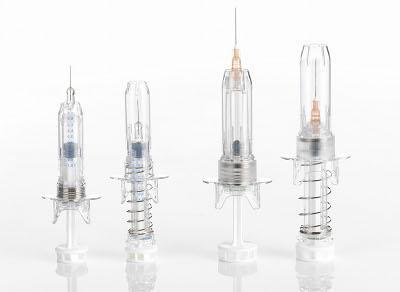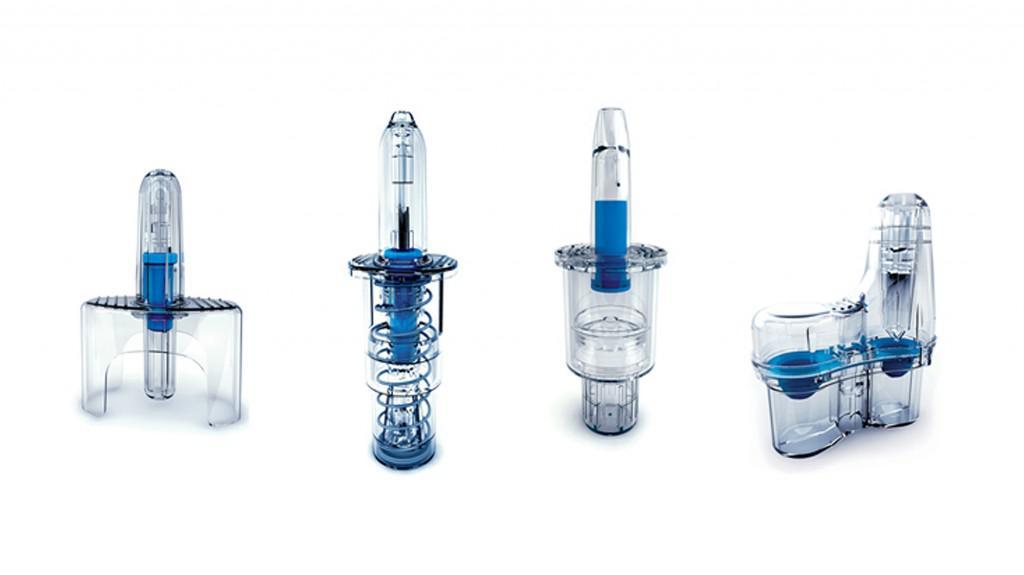The first image is the image on the left, the second image is the image on the right. Considering the images on both sides, is "The image on the right has two syringes." valid? Answer yes or no. No. 